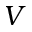Convert formula to latex. <formula><loc_0><loc_0><loc_500><loc_500>V</formula> 